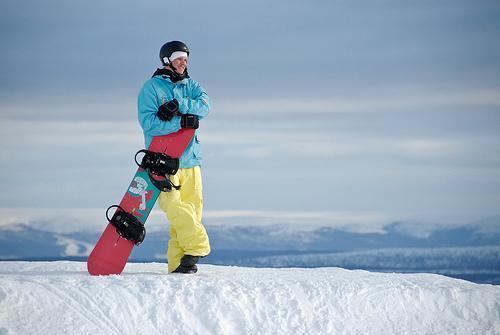How many people are there in this photo?
Give a very brief answer. 1. 